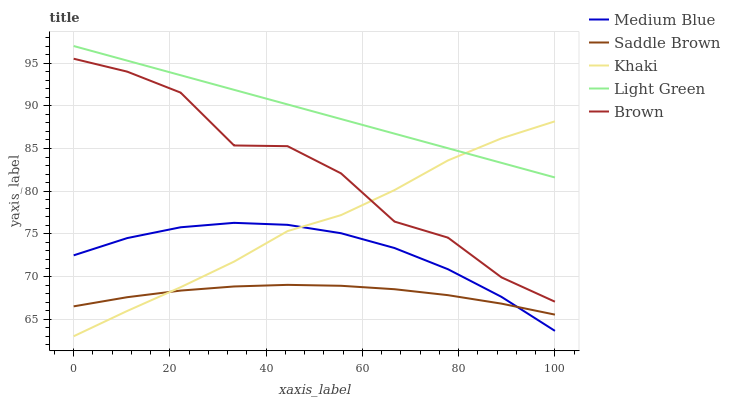Does Khaki have the minimum area under the curve?
Answer yes or no. No. Does Khaki have the maximum area under the curve?
Answer yes or no. No. Is Khaki the smoothest?
Answer yes or no. No. Is Khaki the roughest?
Answer yes or no. No. Does Medium Blue have the lowest value?
Answer yes or no. No. Does Khaki have the highest value?
Answer yes or no. No. Is Medium Blue less than Light Green?
Answer yes or no. Yes. Is Brown greater than Medium Blue?
Answer yes or no. Yes. Does Medium Blue intersect Light Green?
Answer yes or no. No. 